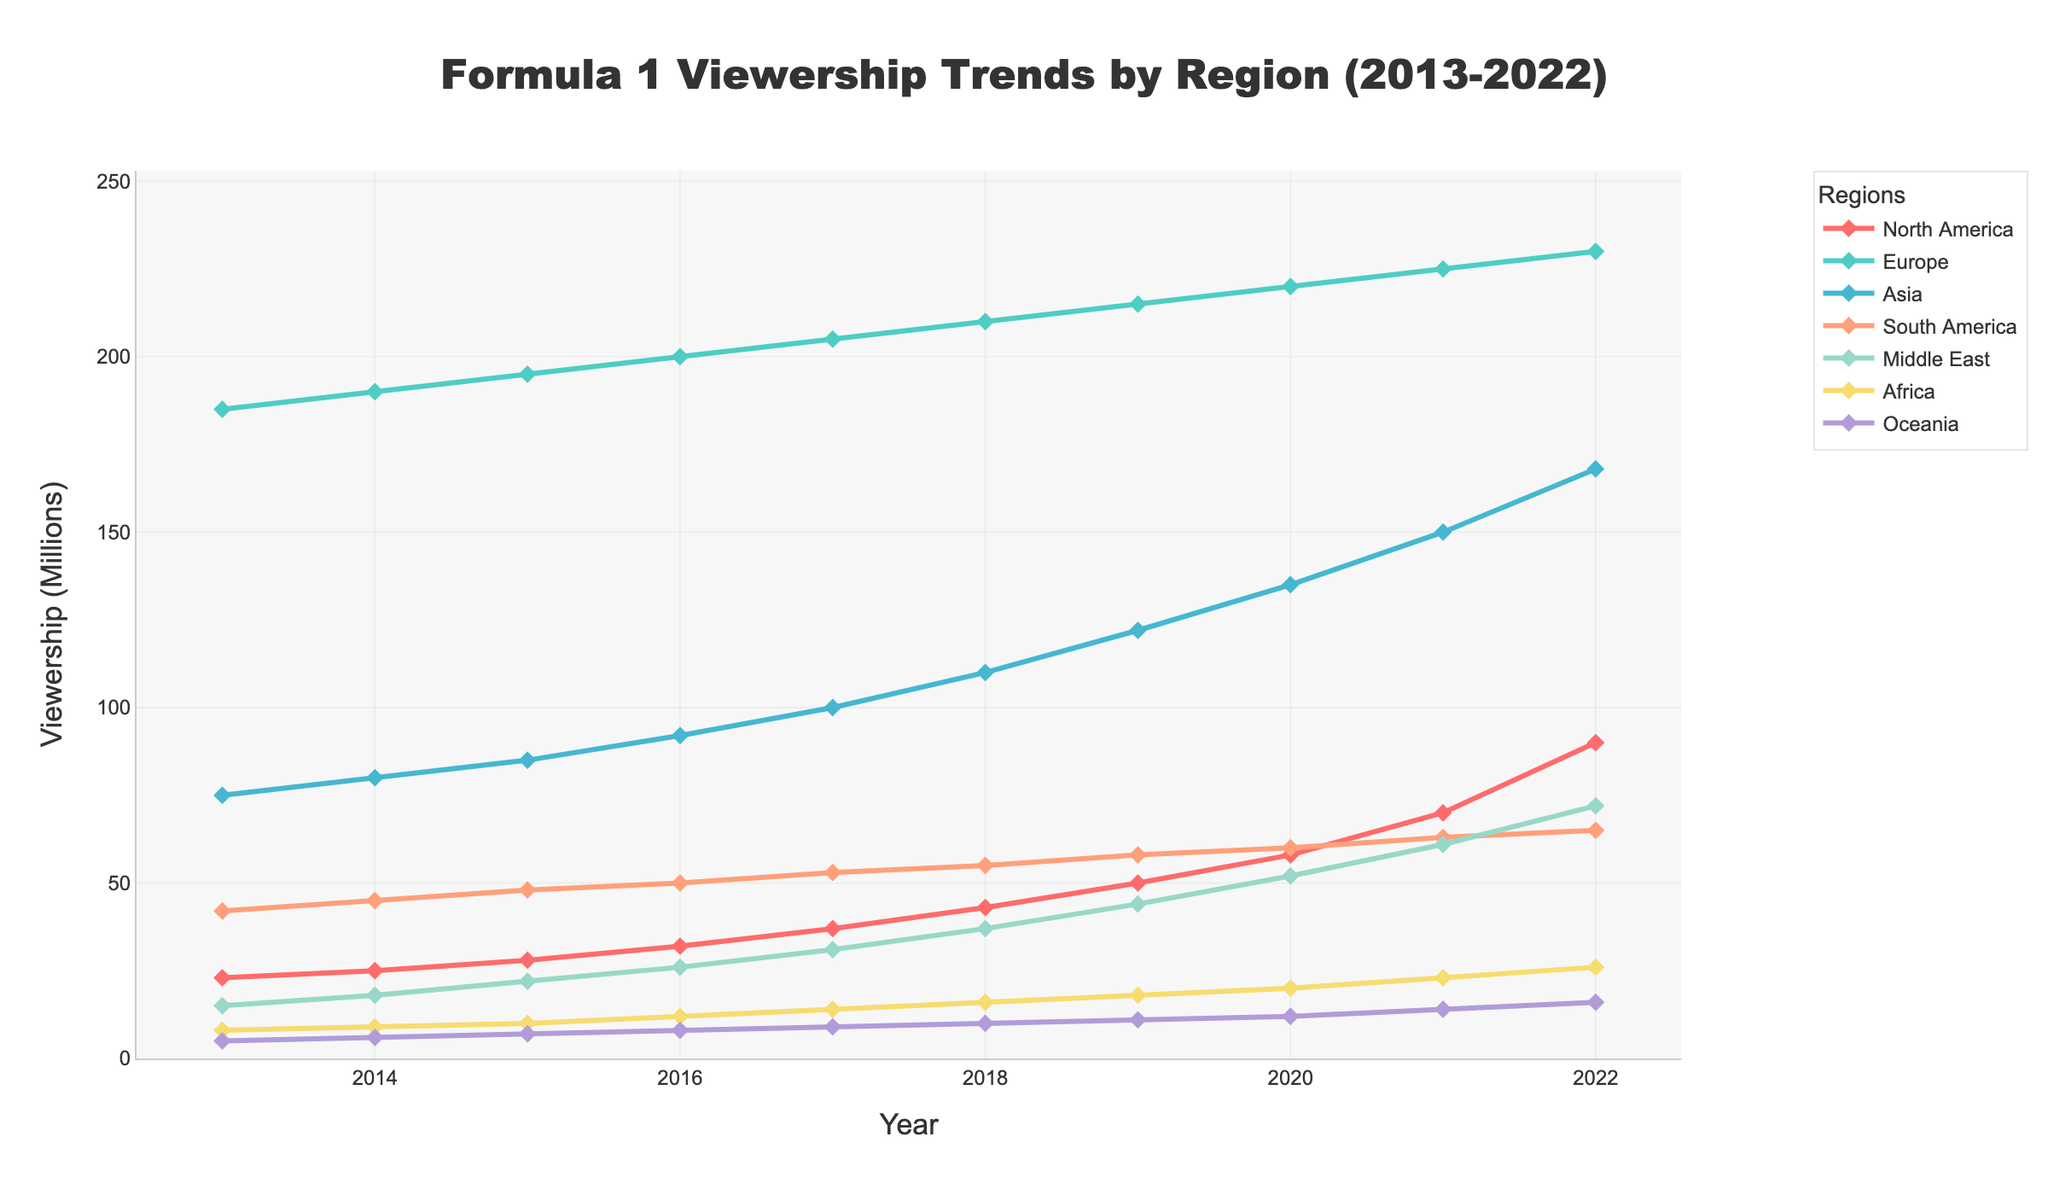What is the overall trend in Formula 1 viewership in North America from 2013 to 2022? To determine the trend, we examine the viewership values for North America across the years. The viewership increased from 23 million in 2013 to 90 million in 2022. This indicates a consistent upward trend.
Answer: Increasing Which region had the highest viewership in 2022? To find the region with the highest viewership in 2022, we compare the viewership numbers for each region in that year. Europe had the highest at 230 million viewers.
Answer: Europe How many more viewers did Europe have compared to North America in 2022? We subtract the viewership of North America (90 million) from the viewership of Europe (230 million) in 2022. 230 - 90 results in 140 million more viewers in Europe.
Answer: 140 million Which regions had a higher viewership than the Middle East in 2018? By comparing the 2018 viewerships, the regions with higher numbers than the Middle East's 37 million are North America (43 million), Europe (210 million), Asia (110 million), and South America (55 million).
Answer: North America, Europe, Asia, South America From 2019 to 2022, which region showed the largest increase in viewership? To find this, we calculate the viewership difference from 2019 to 2022 for each region: North America (90 - 50 = 40 million), Europe (230 - 215 = 15 million), Asia (168 - 122 = 46 million), South America (65 - 58 = 7 million), Middle East (72 - 44 = 28 million), Africa (26 - 18 = 8 million), Oceania (16 - 11 = 5 million). Asia had the largest increase of 46 million.
Answer: Asia What was the average viewership across all regions in 2017? To find the average, we sum the viewership numbers across all regions in 2017 and divide by the number of regions. (37 + 205 + 100 + 53 + 31 + 14 + 9) / 7 = 449 / 7 ≈ 64.14 million.
Answer: 64.14 million Which region had a viewership decline between any two consecutive years, and when? The only region with a viewership decline between consecutive years is South America, which dropped from 50 million in 2016 to 48 million in 2017.
Answer: South America, 2016 to 2017 By how much did viewership in Oceania change from 2013 to 2022? We subtract the 2013 viewership of Oceania (5 million) from the 2022 viewership (16 million), resulting in an increase of 11 million.
Answer: 11 million 